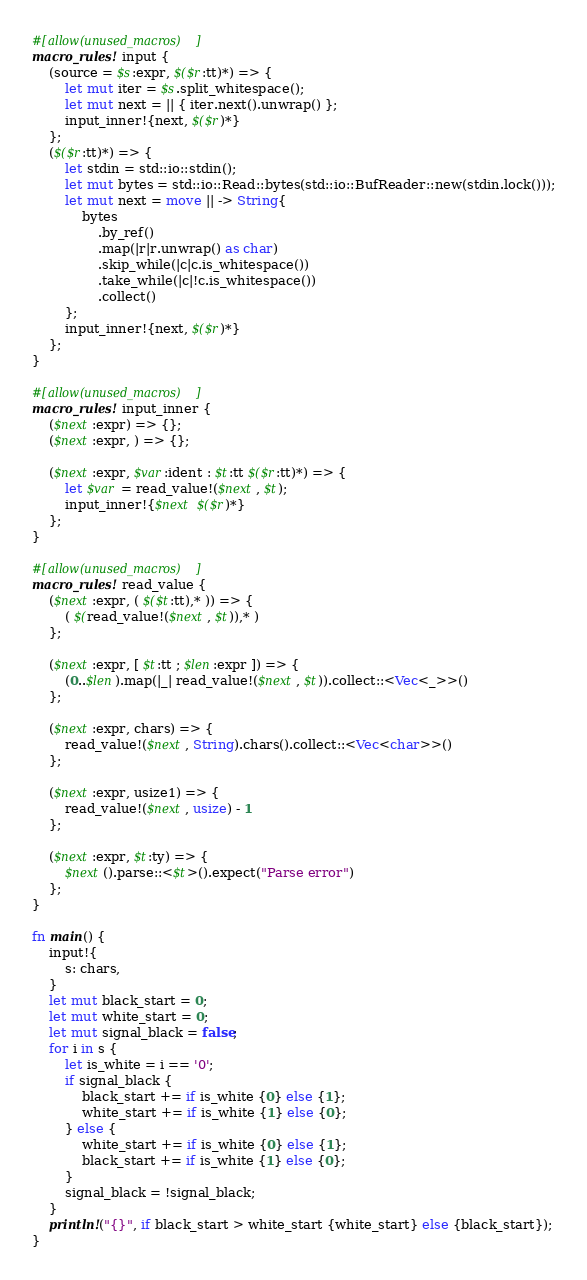Convert code to text. <code><loc_0><loc_0><loc_500><loc_500><_Rust_>
#[allow(unused_macros)]
macro_rules! input {
    (source = $s:expr, $($r:tt)*) => {
        let mut iter = $s.split_whitespace();
        let mut next = || { iter.next().unwrap() };
        input_inner!{next, $($r)*}
    };
    ($($r:tt)*) => {
        let stdin = std::io::stdin();
        let mut bytes = std::io::Read::bytes(std::io::BufReader::new(stdin.lock()));
        let mut next = move || -> String{
            bytes
                .by_ref()
                .map(|r|r.unwrap() as char)
                .skip_while(|c|c.is_whitespace())
                .take_while(|c|!c.is_whitespace())
                .collect()
        };
        input_inner!{next, $($r)*}
    };
}

#[allow(unused_macros)]
macro_rules! input_inner {
    ($next:expr) => {};
    ($next:expr, ) => {};

    ($next:expr, $var:ident : $t:tt $($r:tt)*) => {
        let $var = read_value!($next, $t);
        input_inner!{$next $($r)*}
    };
}

#[allow(unused_macros)]
macro_rules! read_value {
    ($next:expr, ( $($t:tt),* )) => {
        ( $(read_value!($next, $t)),* )
    };

    ($next:expr, [ $t:tt ; $len:expr ]) => {
        (0..$len).map(|_| read_value!($next, $t)).collect::<Vec<_>>()
    };

    ($next:expr, chars) => {
        read_value!($next, String).chars().collect::<Vec<char>>()
    };

    ($next:expr, usize1) => {
        read_value!($next, usize) - 1
    };

    ($next:expr, $t:ty) => {
        $next().parse::<$t>().expect("Parse error")
    };
}

fn main() {
    input!{
        s: chars,
    }
    let mut black_start = 0;
    let mut white_start = 0;
    let mut signal_black = false;
    for i in s {
        let is_white = i == '0';
        if signal_black {
            black_start += if is_white {0} else {1};
            white_start += if is_white {1} else {0};
        } else {
            white_start += if is_white {0} else {1};
            black_start += if is_white {1} else {0};
        }
        signal_black = !signal_black;
    }
    println!("{}", if black_start > white_start {white_start} else {black_start});
}

</code> 